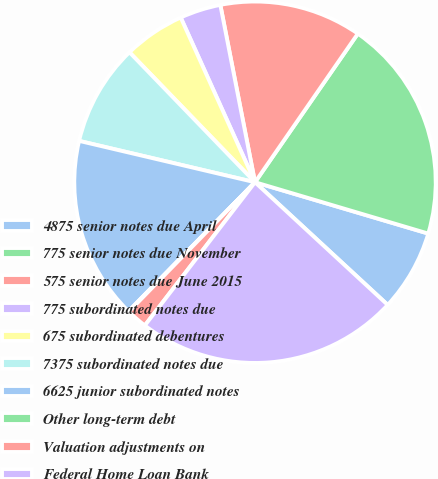<chart> <loc_0><loc_0><loc_500><loc_500><pie_chart><fcel>4875 senior notes due April<fcel>775 senior notes due November<fcel>575 senior notes due June 2015<fcel>775 subordinated notes due<fcel>675 subordinated debentures<fcel>7375 subordinated notes due<fcel>6625 junior subordinated notes<fcel>Other long-term debt<fcel>Valuation adjustments on<fcel>Federal Home Loan Bank<nl><fcel>7.29%<fcel>19.95%<fcel>12.71%<fcel>3.67%<fcel>5.48%<fcel>9.1%<fcel>16.33%<fcel>0.05%<fcel>1.86%<fcel>23.56%<nl></chart> 